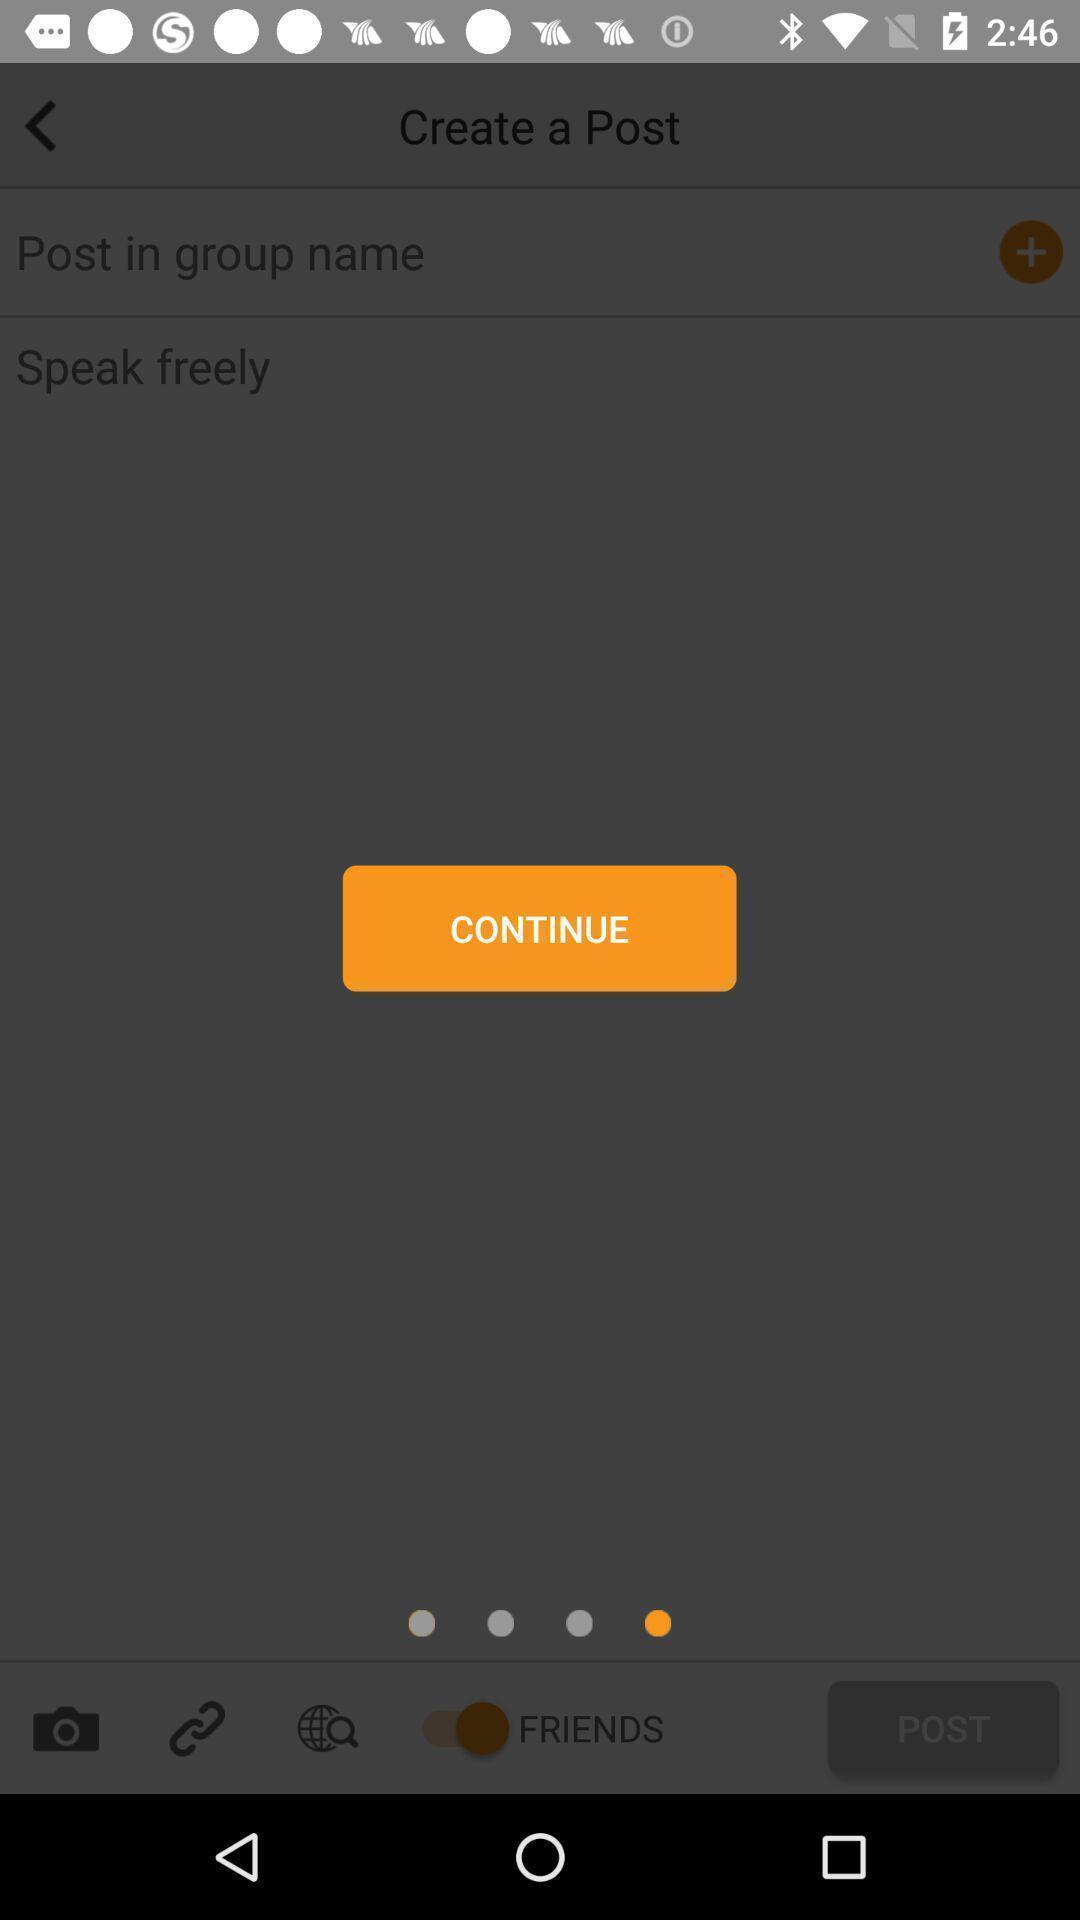What can you discern from this picture? Uploading a post in social app. 